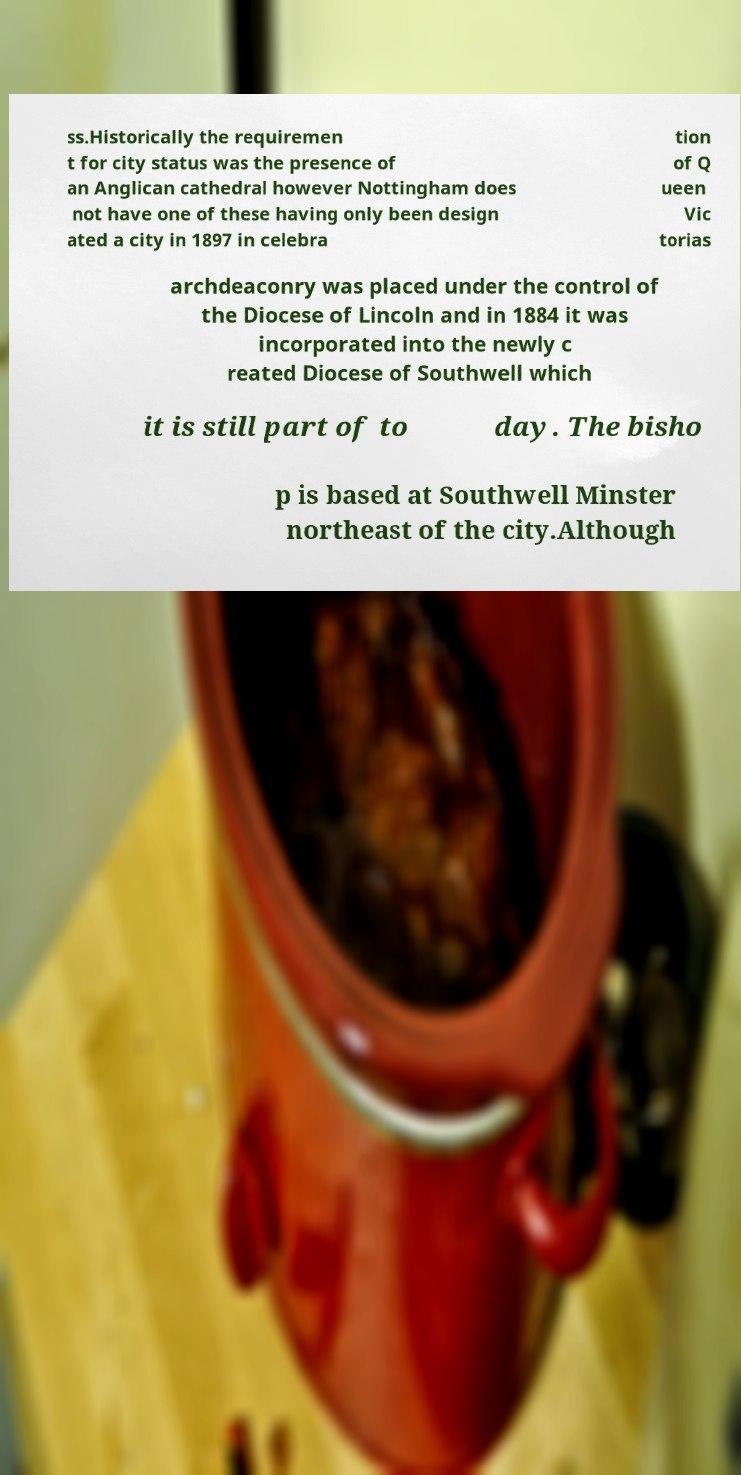Could you assist in decoding the text presented in this image and type it out clearly? ss.Historically the requiremen t for city status was the presence of an Anglican cathedral however Nottingham does not have one of these having only been design ated a city in 1897 in celebra tion of Q ueen Vic torias archdeaconry was placed under the control of the Diocese of Lincoln and in 1884 it was incorporated into the newly c reated Diocese of Southwell which it is still part of to day. The bisho p is based at Southwell Minster northeast of the city.Although 